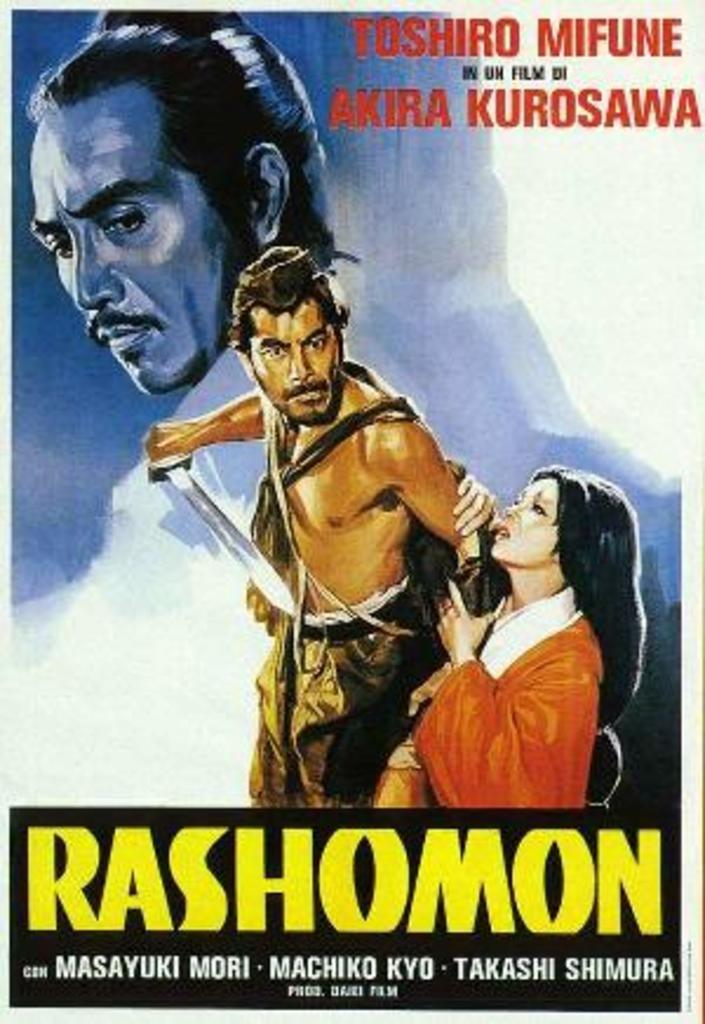<image>
Present a compact description of the photo's key features. A poster for Rashomon shows a man holding a sword. 